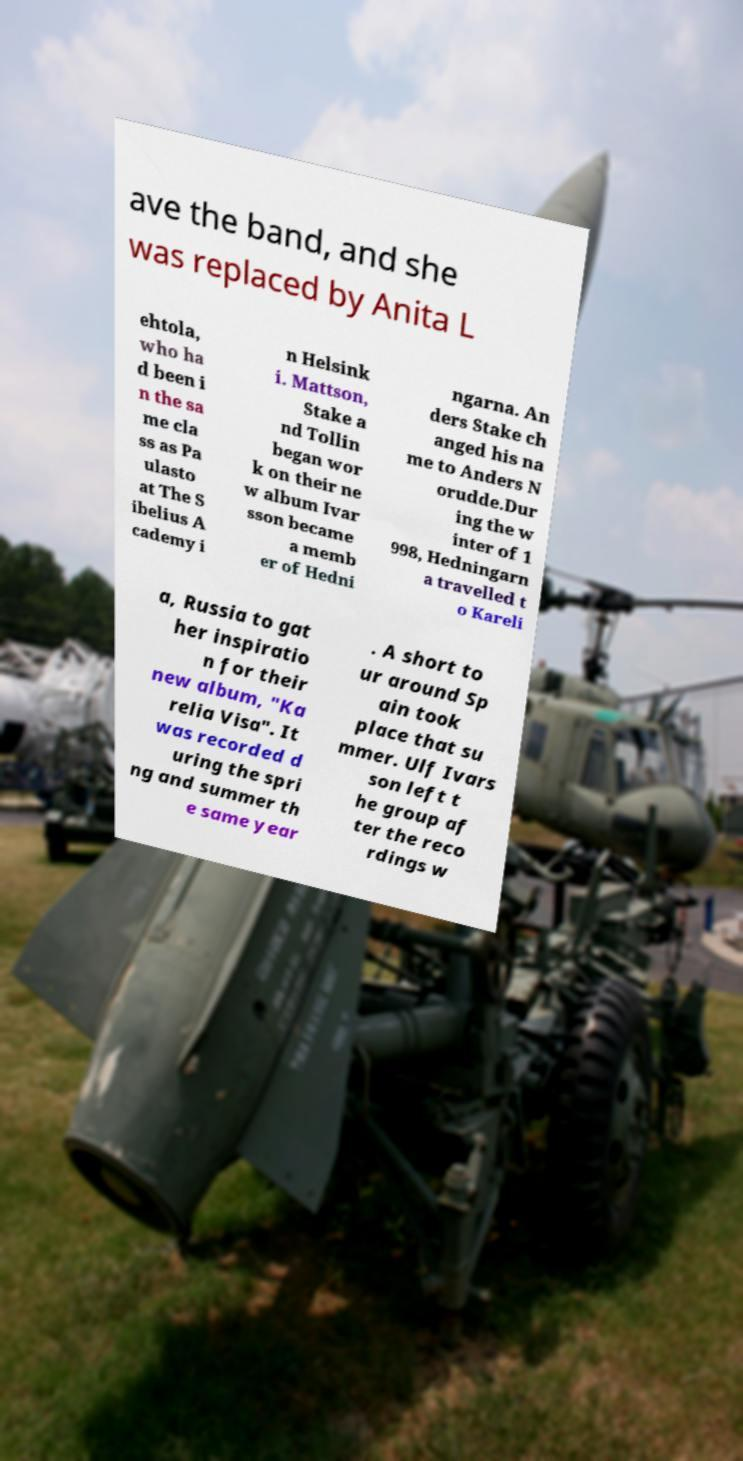For documentation purposes, I need the text within this image transcribed. Could you provide that? ave the band, and she was replaced by Anita L ehtola, who ha d been i n the sa me cla ss as Pa ulasto at The S ibelius A cademy i n Helsink i. Mattson, Stake a nd Tollin began wor k on their ne w album Ivar sson became a memb er of Hedni ngarna. An ders Stake ch anged his na me to Anders N orudde.Dur ing the w inter of 1 998, Hedningarn a travelled t o Kareli a, Russia to gat her inspiratio n for their new album, "Ka relia Visa". It was recorded d uring the spri ng and summer th e same year . A short to ur around Sp ain took place that su mmer. Ulf Ivars son left t he group af ter the reco rdings w 